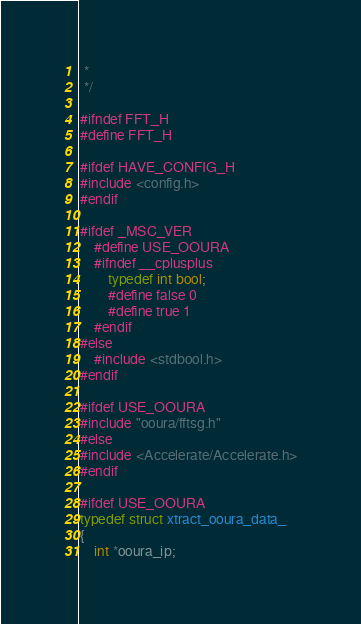Convert code to text. <code><loc_0><loc_0><loc_500><loc_500><_C_> *
 */

#ifndef FFT_H
#define FFT_H

#ifdef HAVE_CONFIG_H
#include <config.h>
#endif

#ifdef _MSC_VER
	#define USE_OOURA
	#ifndef __cplusplus
		typedef int bool;
		#define false 0
		#define true 1
	#endif
#else
	#include <stdbool.h>
#endif

#ifdef USE_OOURA
#include "ooura/fftsg.h"
#else
#include <Accelerate/Accelerate.h>
#endif

#ifdef USE_OOURA
typedef struct xtract_ooura_data_
{
    int *ooura_ip;</code> 